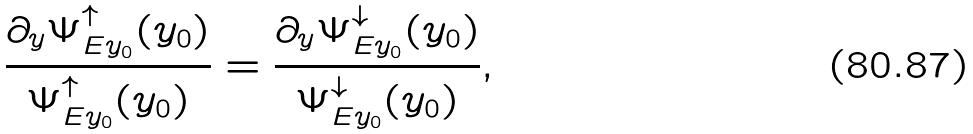Convert formula to latex. <formula><loc_0><loc_0><loc_500><loc_500>\frac { \partial _ { y } \Psi ^ { \uparrow } _ { E y _ { 0 } } ( y _ { 0 } ) } { \Psi ^ { \uparrow } _ { E y _ { 0 } } ( y _ { 0 } ) } = \frac { \partial _ { y } \Psi ^ { \downarrow } _ { E y _ { 0 } } ( y _ { 0 } ) } { \Psi ^ { \downarrow } _ { E y _ { 0 } } ( y _ { 0 } ) } ,</formula> 